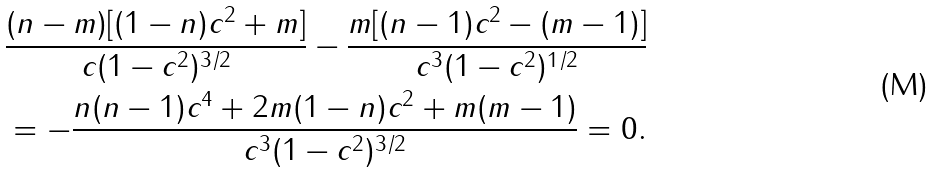Convert formula to latex. <formula><loc_0><loc_0><loc_500><loc_500>& \frac { ( n - m ) [ ( 1 - n ) c ^ { 2 } + m ] } { c ( 1 - c ^ { 2 } ) ^ { 3 / 2 } } - \frac { m [ ( n - 1 ) c ^ { 2 } - ( m - 1 ) ] } { c ^ { 3 } ( 1 - c ^ { 2 } ) ^ { 1 / 2 } } \\ & = - \frac { n ( n - 1 ) c ^ { 4 } + 2 m ( 1 - n ) c ^ { 2 } + m ( m - 1 ) } { c ^ { 3 } ( 1 - c ^ { 2 } ) ^ { 3 / 2 } } = 0 .</formula> 